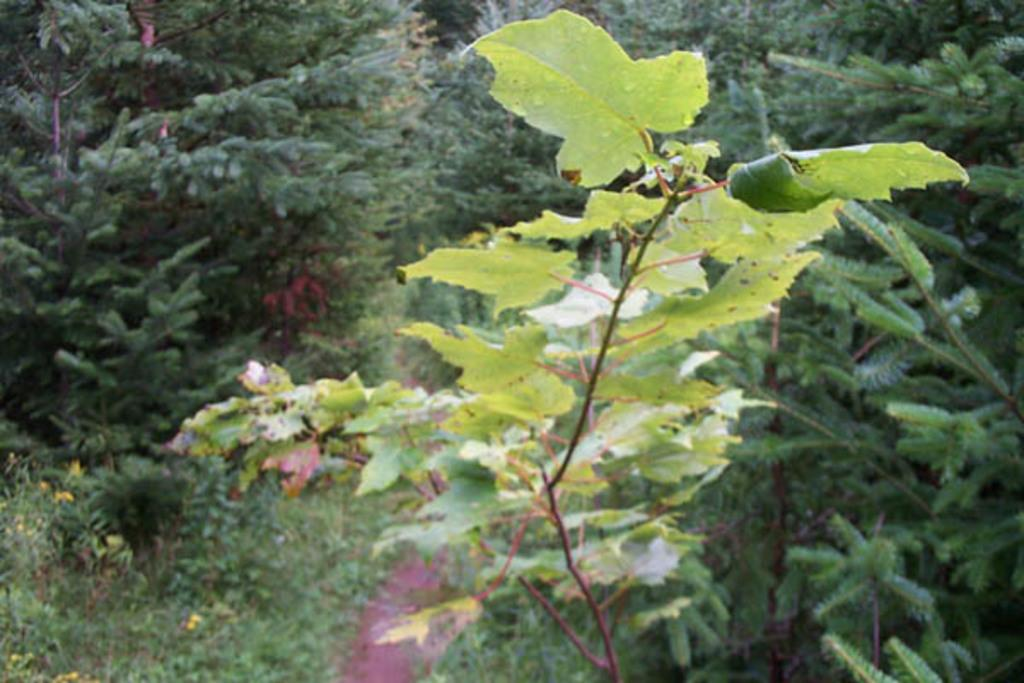What type of plant is visible in the image? There is a plant with medium-sized leaves in the image. What is located behind the plant? There is a path behind the plant. What can be seen on either side of the path? There are numerous plants and trees on either side of the path. What type of advice can be heard coming from the stove in the image? There is no stove present in the image, so it is not possible to determine what advice might be heard. 